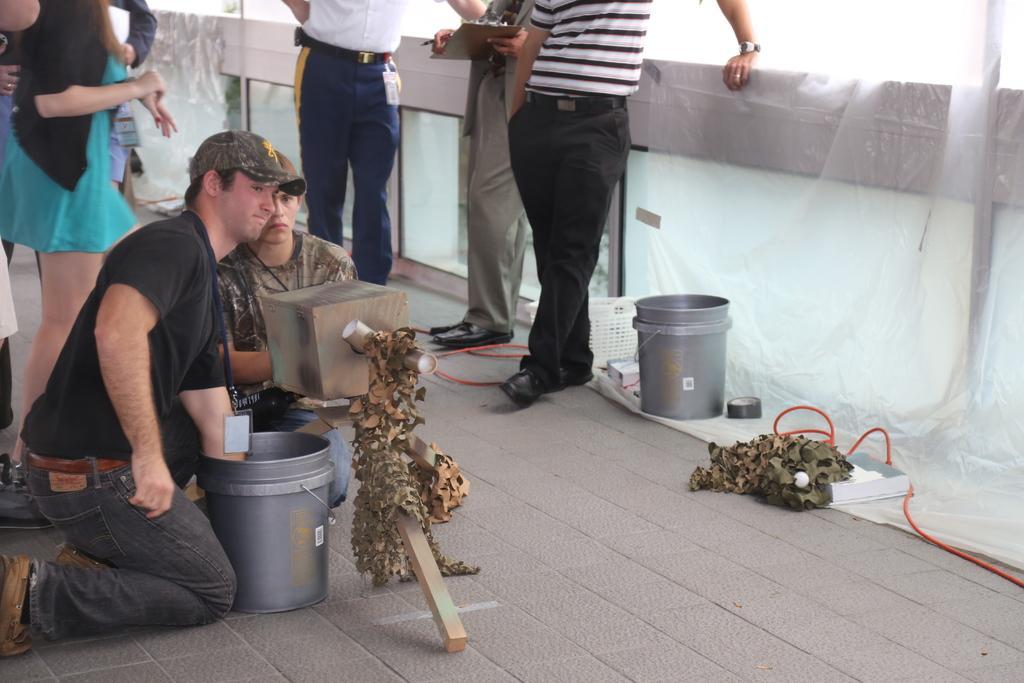Can you describe this image briefly? In this image, we can see few people. Few people are standing. Here we can see a person's knee down on the floor. Here we can see two buckets, some wooden pieces, tape, wires, cover. Top of the image, a person is holding a pad and pen. 